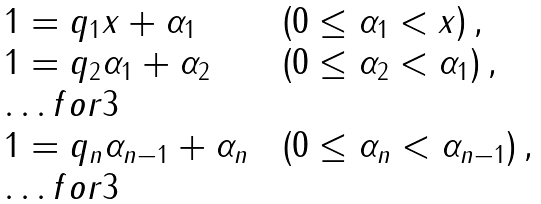Convert formula to latex. <formula><loc_0><loc_0><loc_500><loc_500>\begin{array} { l l l } 1 = q _ { 1 } x + \alpha _ { 1 } & & \left ( 0 \leq \alpha _ { 1 } < x \right ) , \\ 1 = q _ { 2 } \alpha _ { 1 } + \alpha _ { 2 } & & \left ( 0 \leq \alpha _ { 2 } < \alpha _ { 1 } \right ) , \\ \hdots f o r { 3 } \\ 1 = q _ { n } \alpha _ { n - 1 } + \alpha _ { n } & & \left ( 0 \leq \alpha _ { n } < \alpha _ { n - 1 } \right ) , \\ \hdots f o r { 3 } \end{array}</formula> 